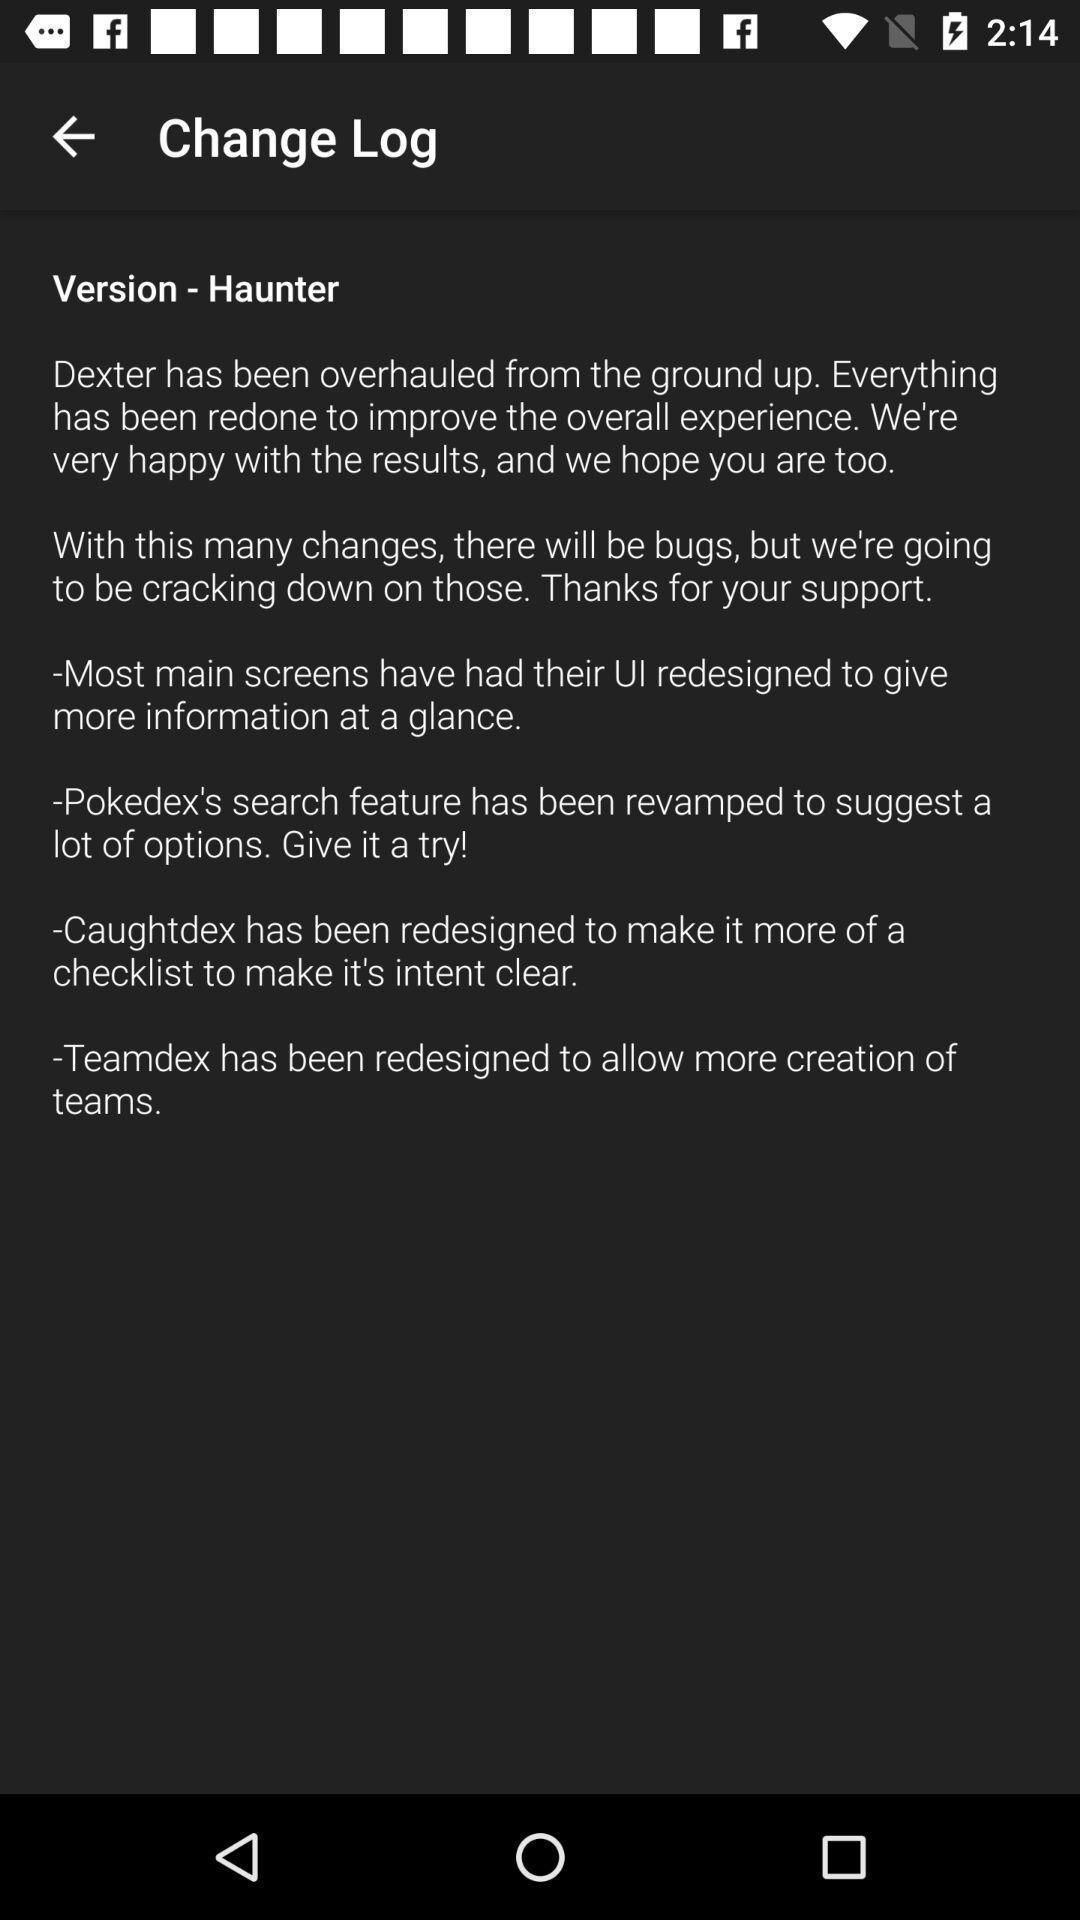Please provide a description for this image. Screen displaying about the version. 